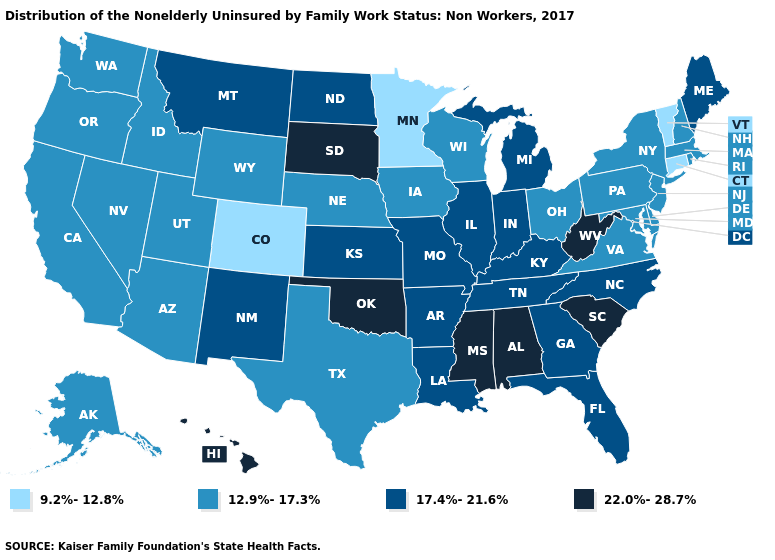What is the value of Maine?
Be succinct. 17.4%-21.6%. Among the states that border Maine , which have the highest value?
Keep it brief. New Hampshire. What is the highest value in states that border North Carolina?
Give a very brief answer. 22.0%-28.7%. Which states have the highest value in the USA?
Write a very short answer. Alabama, Hawaii, Mississippi, Oklahoma, South Carolina, South Dakota, West Virginia. What is the highest value in the USA?
Keep it brief. 22.0%-28.7%. Is the legend a continuous bar?
Be succinct. No. Name the states that have a value in the range 17.4%-21.6%?
Quick response, please. Arkansas, Florida, Georgia, Illinois, Indiana, Kansas, Kentucky, Louisiana, Maine, Michigan, Missouri, Montana, New Mexico, North Carolina, North Dakota, Tennessee. What is the value of Colorado?
Write a very short answer. 9.2%-12.8%. Which states have the lowest value in the USA?
Quick response, please. Colorado, Connecticut, Minnesota, Vermont. Does Vermont have the same value as Colorado?
Short answer required. Yes. Among the states that border Maryland , does West Virginia have the lowest value?
Give a very brief answer. No. What is the value of Maryland?
Write a very short answer. 12.9%-17.3%. What is the lowest value in states that border Rhode Island?
Give a very brief answer. 9.2%-12.8%. Which states have the highest value in the USA?
Give a very brief answer. Alabama, Hawaii, Mississippi, Oklahoma, South Carolina, South Dakota, West Virginia. Among the states that border Virginia , does West Virginia have the highest value?
Give a very brief answer. Yes. 